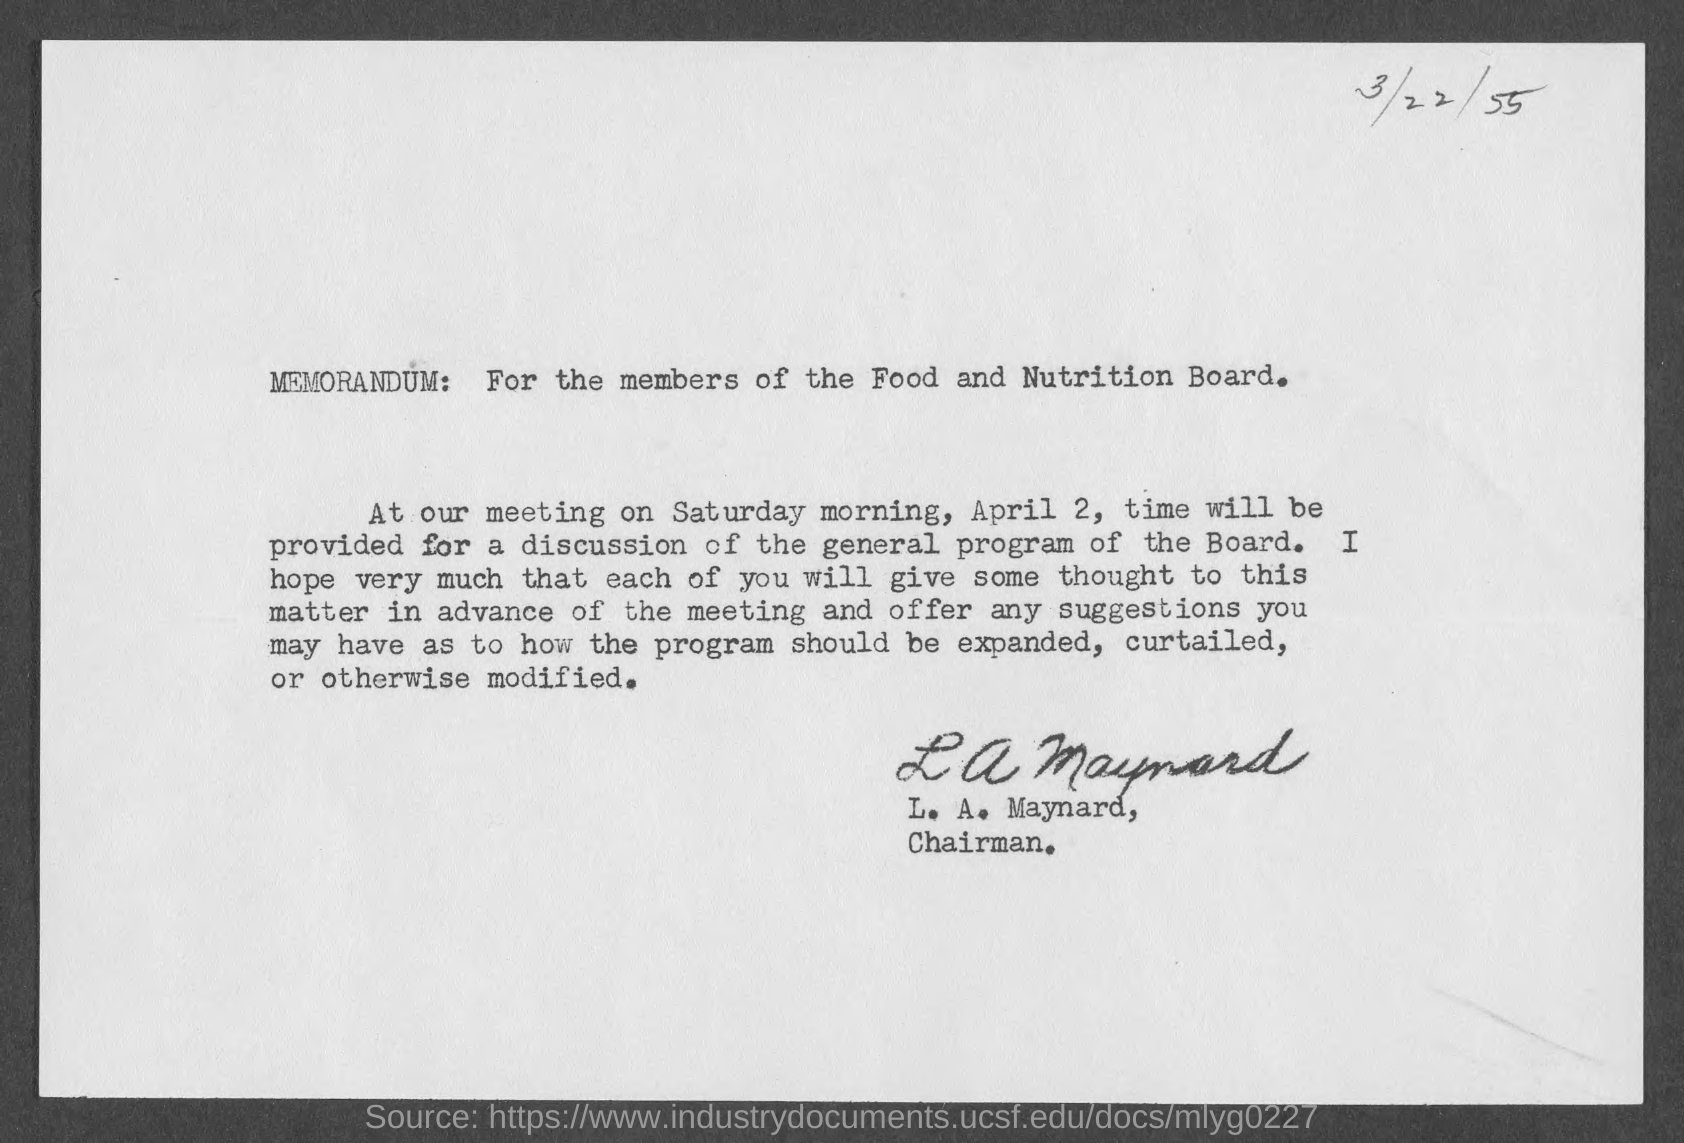Mention a couple of crucial points in this snapshot. The document is dated as of March 22nd, 1955. The Memorandum is intended for the members of the Food and Nutrition Board. The document has been signed by L. A. Maynard. 